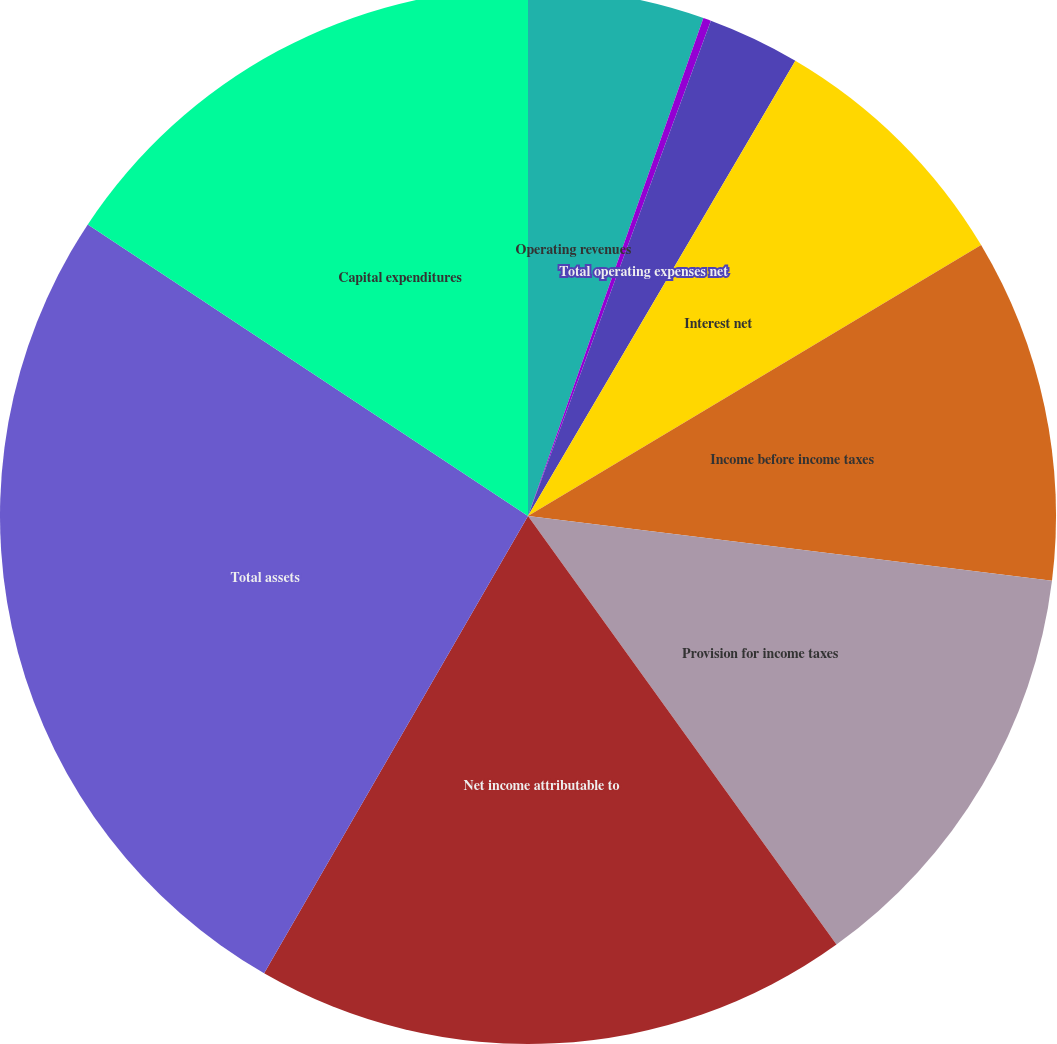<chart> <loc_0><loc_0><loc_500><loc_500><pie_chart><fcel>Operating revenues<fcel>Depreciation and amortization<fcel>Total operating expenses net<fcel>Interest net<fcel>Income before income taxes<fcel>Provision for income taxes<fcel>Net income attributable to<fcel>Total assets<fcel>Capital expenditures<nl><fcel>5.39%<fcel>0.24%<fcel>2.82%<fcel>7.97%<fcel>10.54%<fcel>13.11%<fcel>18.26%<fcel>25.98%<fcel>15.69%<nl></chart> 